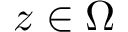<formula> <loc_0><loc_0><loc_500><loc_500>z \in \Omega</formula> 